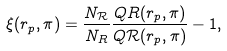Convert formula to latex. <formula><loc_0><loc_0><loc_500><loc_500>\xi ( r _ { p } , \pi ) = \frac { N _ { \mathcal { R } } } { N _ { R } } \frac { Q R ( r _ { p } , \pi ) } { Q \mathcal { R } ( r _ { p } , \pi ) } - 1 ,</formula> 